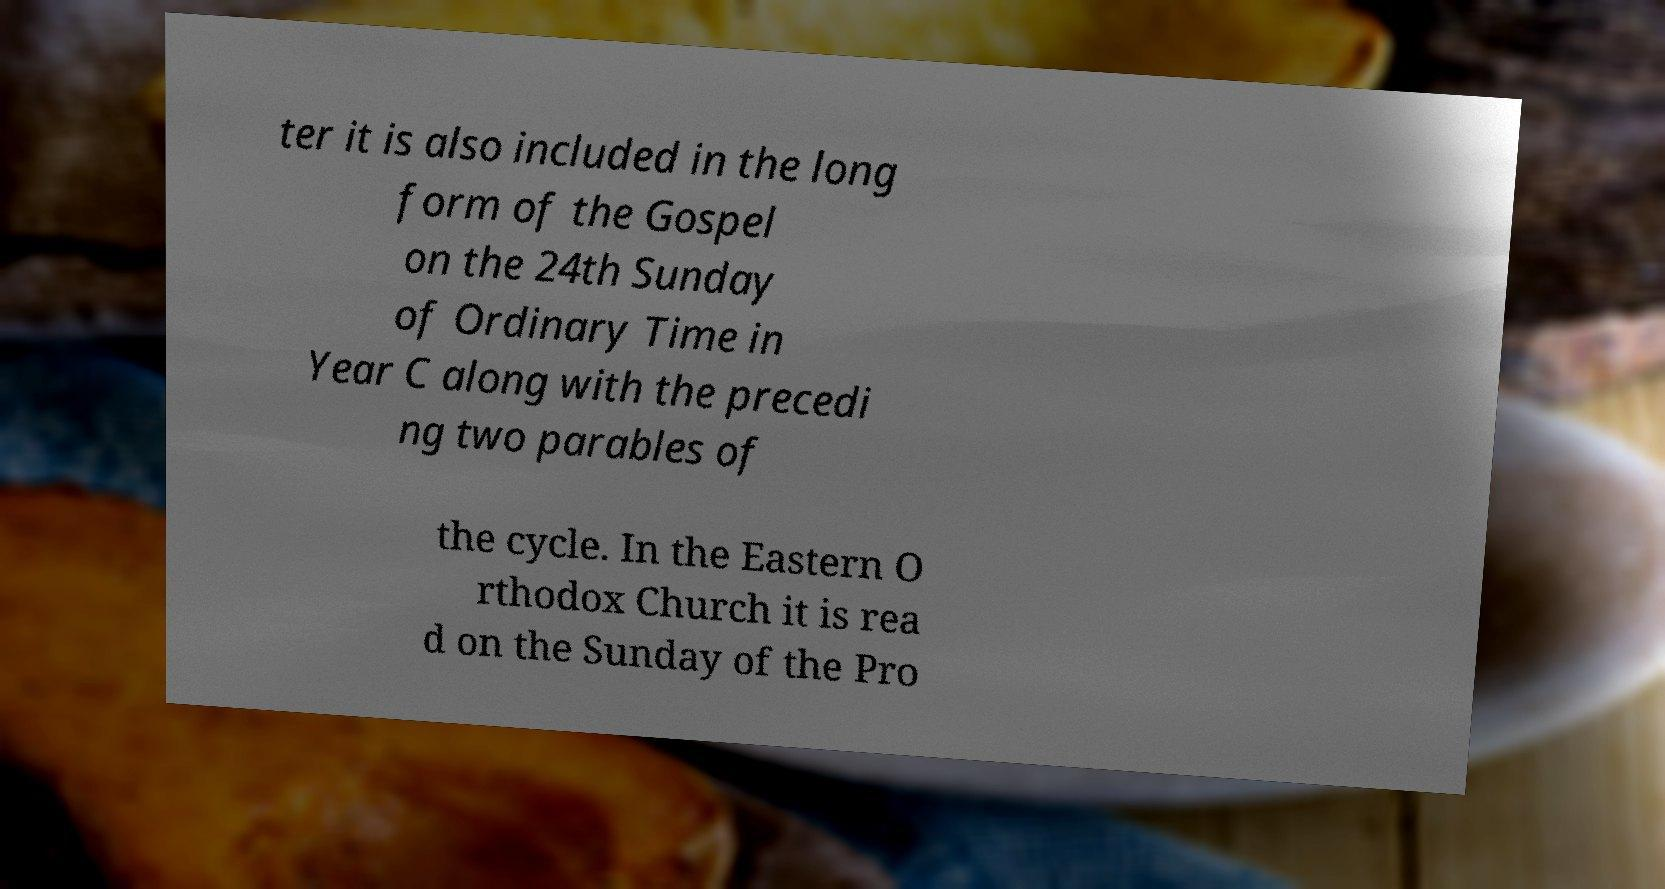What messages or text are displayed in this image? I need them in a readable, typed format. ter it is also included in the long form of the Gospel on the 24th Sunday of Ordinary Time in Year C along with the precedi ng two parables of the cycle. In the Eastern O rthodox Church it is rea d on the Sunday of the Pro 